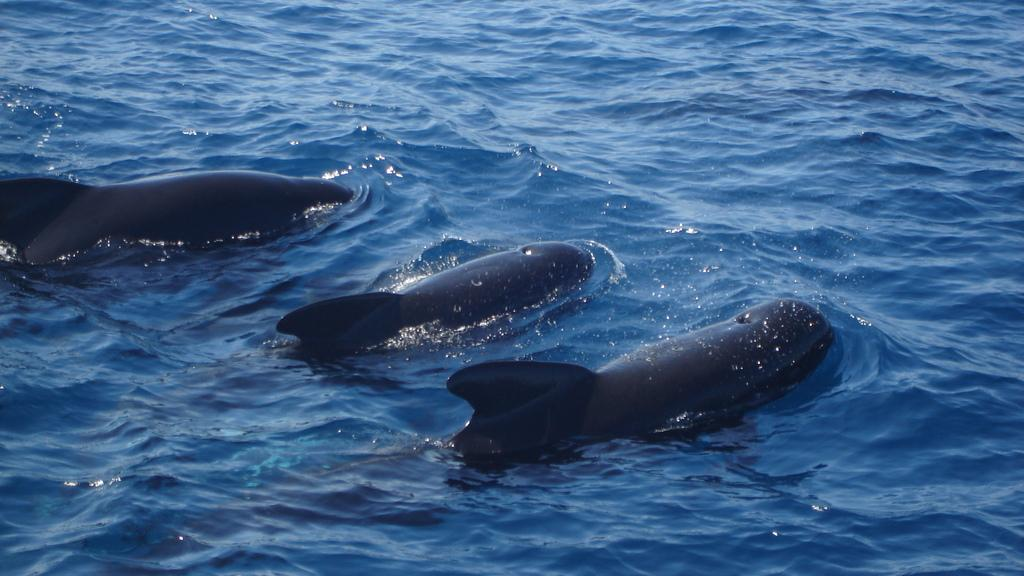What type of animals can be seen in the image? Animals can be seen in the water. Can you describe the setting where the animals are located? The animals are in the water, which suggests they might be aquatic or swimming. How many animals are visible in the image? The number of animals cannot be determined from the provided facts. What type of ants can be seen carrying the plot in the image? There are no ants or plots present in the image; it features animals in the water. 